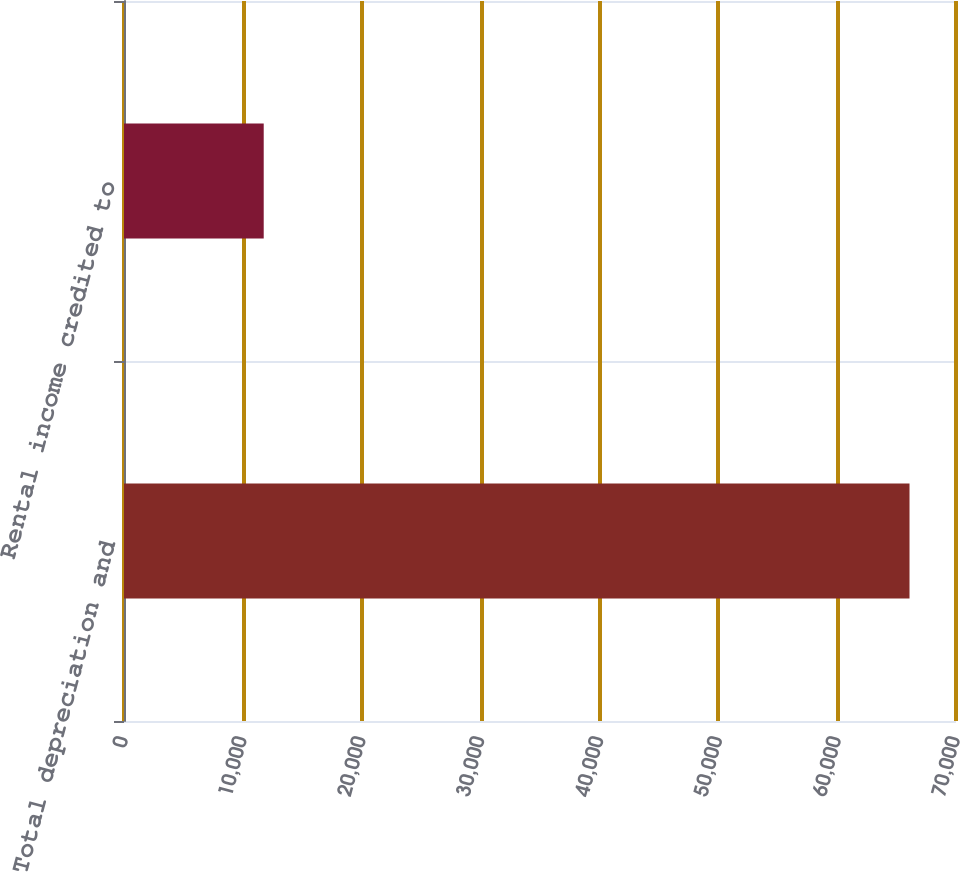Convert chart. <chart><loc_0><loc_0><loc_500><loc_500><bar_chart><fcel>Total depreciation and<fcel>Rental income credited to<nl><fcel>66089<fcel>11755<nl></chart> 